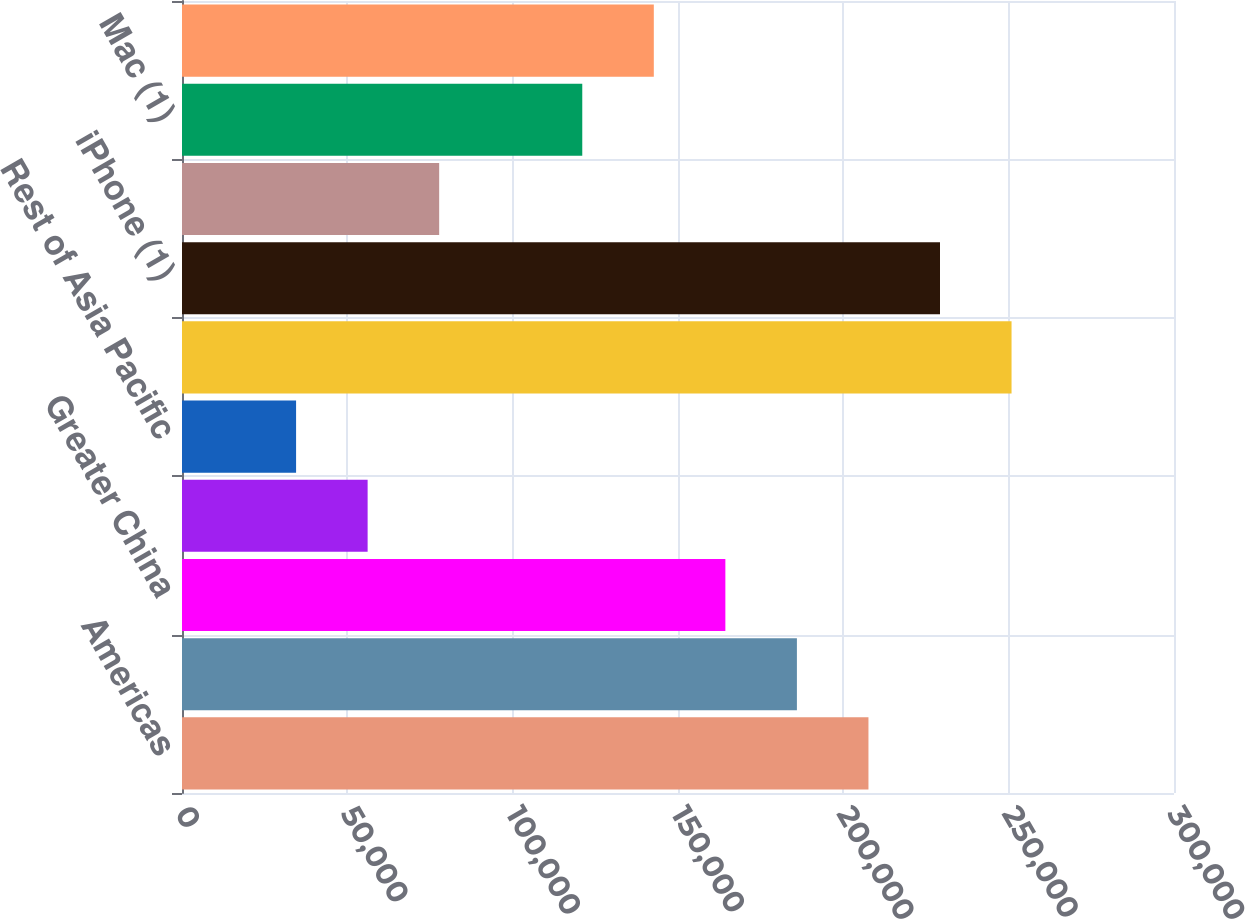<chart> <loc_0><loc_0><loc_500><loc_500><bar_chart><fcel>Americas<fcel>Europe<fcel>Greater China<fcel>Japan<fcel>Rest of Asia Pacific<fcel>Total net sales<fcel>iPhone (1)<fcel>iPad (1)<fcel>Mac (1)<fcel>Services (2)<nl><fcel>207597<fcel>185960<fcel>164323<fcel>56137.2<fcel>34500.1<fcel>250871<fcel>229234<fcel>77774.3<fcel>121048<fcel>142686<nl></chart> 